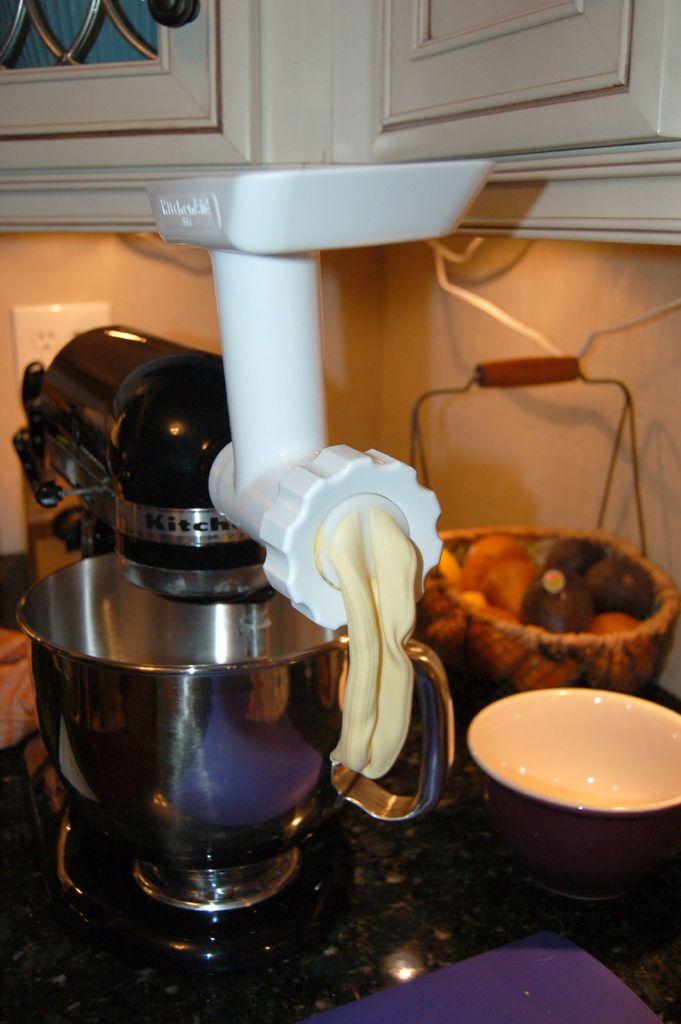What is the brand?
Offer a terse response. Kitchenaid. 